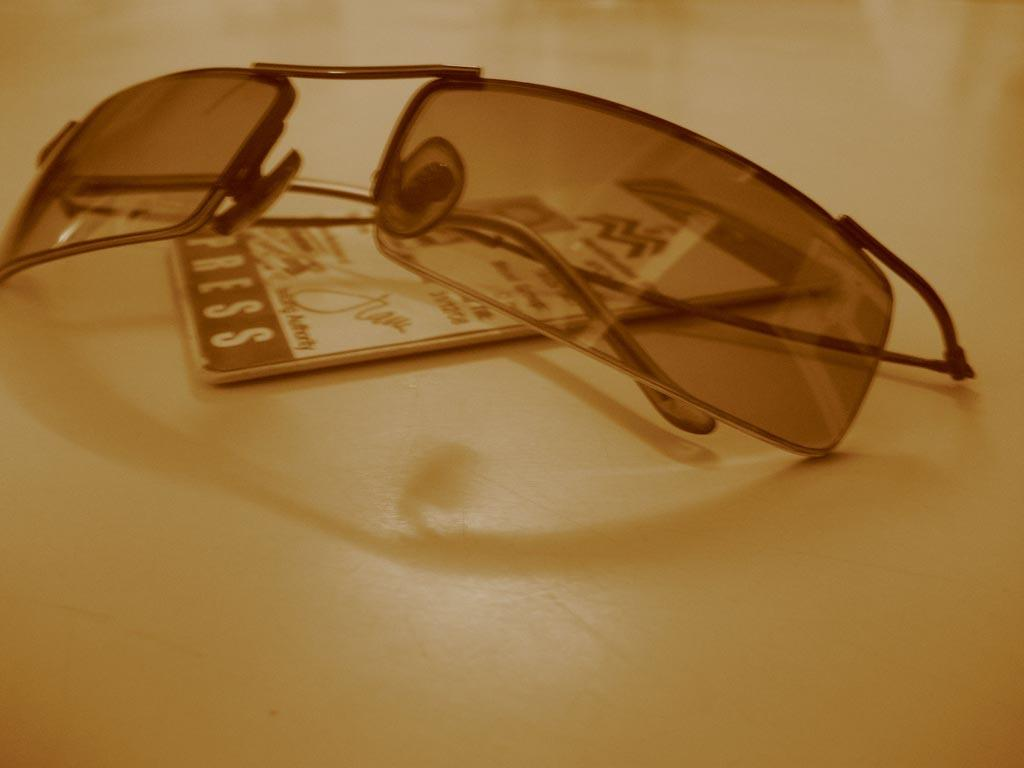What type of accessory is present in the image? There are sunglasses in the image. What other object can be seen on the table in the image? There is an ID card in the image. Where are the sunglasses and ID card located? Both objects are on a table. What is the mass of the wealth displayed in the image? There is no wealth displayed in the image, as the only objects mentioned are sunglasses and an ID card. 